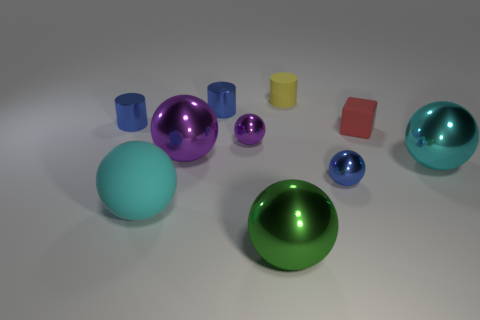What number of objects are either metal objects behind the cube or large green shiny objects?
Your answer should be very brief. 3. Is the material of the yellow thing the same as the green sphere?
Keep it short and to the point. No. What is the size of the green thing that is the same shape as the small purple object?
Your answer should be compact. Large. Is the shape of the blue metal thing that is in front of the small cube the same as the purple thing behind the large purple ball?
Offer a very short reply. Yes. Is the size of the blue metallic ball the same as the rubber object to the left of the green metal ball?
Your answer should be compact. No. How many other things are the same material as the yellow thing?
Give a very brief answer. 2. Is there any other thing that has the same shape as the green object?
Keep it short and to the point. Yes. There is a small thing behind the small blue metal cylinder to the right of the rubber thing in front of the tiny red object; what is its color?
Ensure brevity in your answer.  Yellow. There is a tiny object that is on the left side of the blue metal ball and right of the big green object; what shape is it?
Offer a terse response. Cylinder. Are there any other things that have the same size as the green shiny sphere?
Your answer should be compact. Yes. 